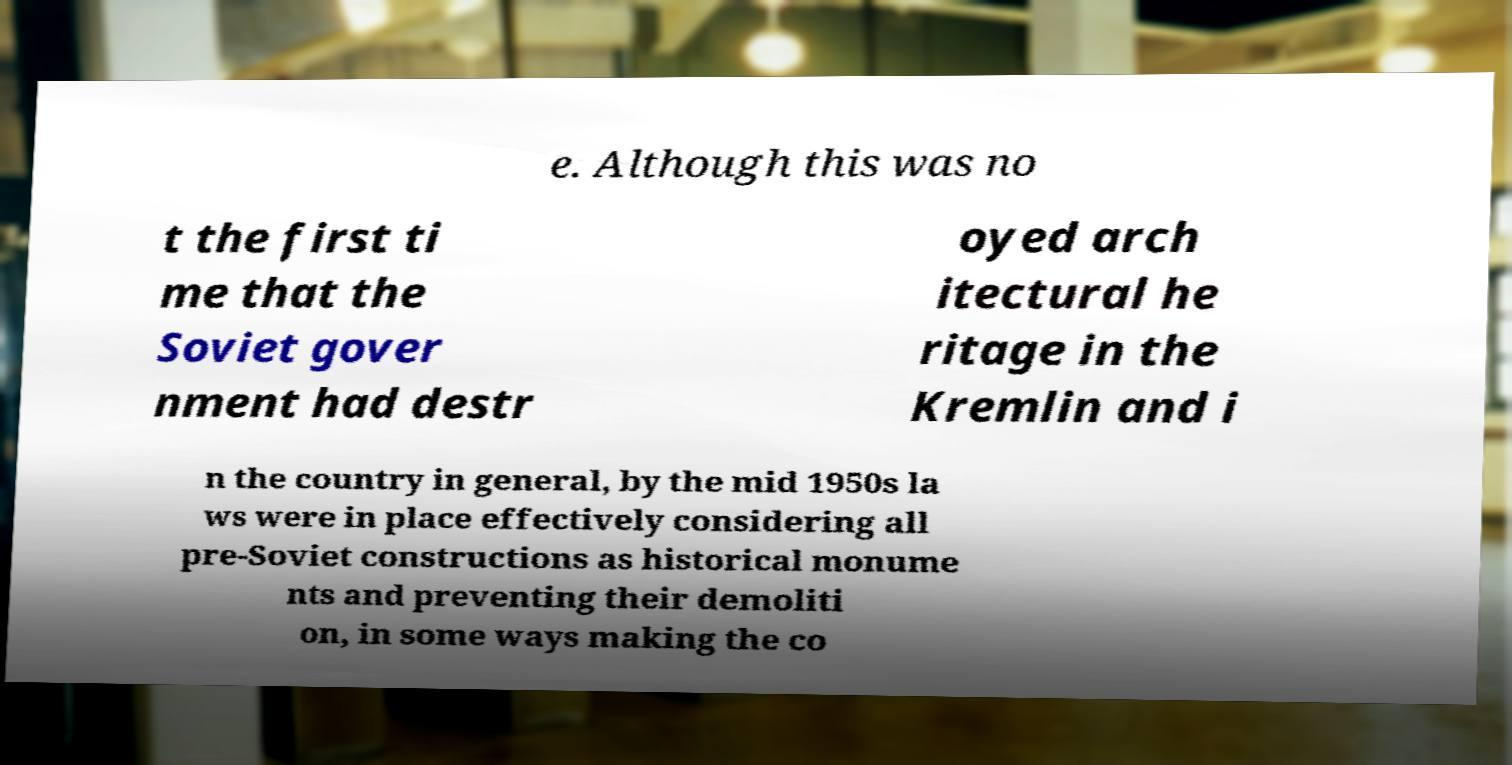What messages or text are displayed in this image? I need them in a readable, typed format. e. Although this was no t the first ti me that the Soviet gover nment had destr oyed arch itectural he ritage in the Kremlin and i n the country in general, by the mid 1950s la ws were in place effectively considering all pre-Soviet constructions as historical monume nts and preventing their demoliti on, in some ways making the co 